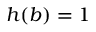Convert formula to latex. <formula><loc_0><loc_0><loc_500><loc_500>h ( b ) = 1</formula> 